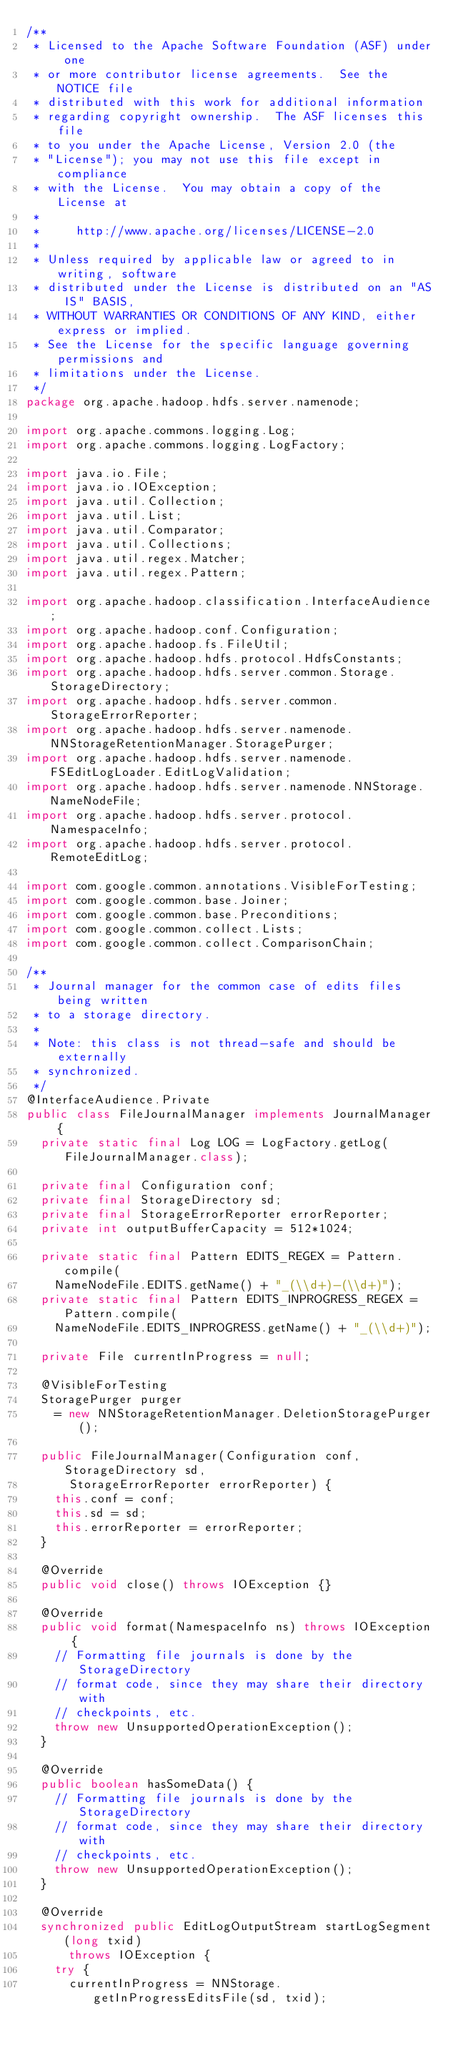Convert code to text. <code><loc_0><loc_0><loc_500><loc_500><_Java_>/**
 * Licensed to the Apache Software Foundation (ASF) under one
 * or more contributor license agreements.  See the NOTICE file
 * distributed with this work for additional information
 * regarding copyright ownership.  The ASF licenses this file
 * to you under the Apache License, Version 2.0 (the
 * "License"); you may not use this file except in compliance
 * with the License.  You may obtain a copy of the License at
 *
 *     http://www.apache.org/licenses/LICENSE-2.0
 *
 * Unless required by applicable law or agreed to in writing, software
 * distributed under the License is distributed on an "AS IS" BASIS,
 * WITHOUT WARRANTIES OR CONDITIONS OF ANY KIND, either express or implied.
 * See the License for the specific language governing permissions and
 * limitations under the License.
 */
package org.apache.hadoop.hdfs.server.namenode;

import org.apache.commons.logging.Log;
import org.apache.commons.logging.LogFactory;

import java.io.File;
import java.io.IOException;
import java.util.Collection;
import java.util.List;
import java.util.Comparator;
import java.util.Collections;
import java.util.regex.Matcher;
import java.util.regex.Pattern;

import org.apache.hadoop.classification.InterfaceAudience;
import org.apache.hadoop.conf.Configuration;
import org.apache.hadoop.fs.FileUtil;
import org.apache.hadoop.hdfs.protocol.HdfsConstants;
import org.apache.hadoop.hdfs.server.common.Storage.StorageDirectory;
import org.apache.hadoop.hdfs.server.common.StorageErrorReporter;
import org.apache.hadoop.hdfs.server.namenode.NNStorageRetentionManager.StoragePurger;
import org.apache.hadoop.hdfs.server.namenode.FSEditLogLoader.EditLogValidation;
import org.apache.hadoop.hdfs.server.namenode.NNStorage.NameNodeFile;
import org.apache.hadoop.hdfs.server.protocol.NamespaceInfo;
import org.apache.hadoop.hdfs.server.protocol.RemoteEditLog;

import com.google.common.annotations.VisibleForTesting;
import com.google.common.base.Joiner;
import com.google.common.base.Preconditions;
import com.google.common.collect.Lists;
import com.google.common.collect.ComparisonChain;

/**
 * Journal manager for the common case of edits files being written
 * to a storage directory.
 * 
 * Note: this class is not thread-safe and should be externally
 * synchronized.
 */
@InterfaceAudience.Private
public class FileJournalManager implements JournalManager {
  private static final Log LOG = LogFactory.getLog(FileJournalManager.class);

  private final Configuration conf;
  private final StorageDirectory sd;
  private final StorageErrorReporter errorReporter;
  private int outputBufferCapacity = 512*1024;

  private static final Pattern EDITS_REGEX = Pattern.compile(
    NameNodeFile.EDITS.getName() + "_(\\d+)-(\\d+)");
  private static final Pattern EDITS_INPROGRESS_REGEX = Pattern.compile(
    NameNodeFile.EDITS_INPROGRESS.getName() + "_(\\d+)");

  private File currentInProgress = null;

  @VisibleForTesting
  StoragePurger purger
    = new NNStorageRetentionManager.DeletionStoragePurger();

  public FileJournalManager(Configuration conf, StorageDirectory sd,
      StorageErrorReporter errorReporter) {
    this.conf = conf;
    this.sd = sd;
    this.errorReporter = errorReporter;
  }

  @Override 
  public void close() throws IOException {}
  
  @Override
  public void format(NamespaceInfo ns) throws IOException {
    // Formatting file journals is done by the StorageDirectory
    // format code, since they may share their directory with
    // checkpoints, etc.
    throw new UnsupportedOperationException();
  }
  
  @Override
  public boolean hasSomeData() {
    // Formatting file journals is done by the StorageDirectory
    // format code, since they may share their directory with
    // checkpoints, etc.
    throw new UnsupportedOperationException();
  }

  @Override
  synchronized public EditLogOutputStream startLogSegment(long txid) 
      throws IOException {
    try {
      currentInProgress = NNStorage.getInProgressEditsFile(sd, txid);</code> 